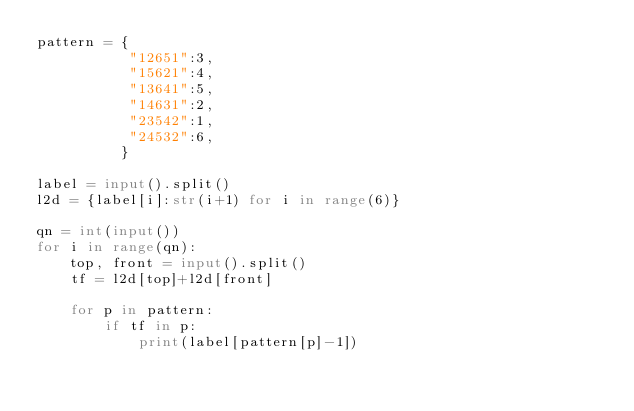Convert code to text. <code><loc_0><loc_0><loc_500><loc_500><_Python_>pattern = {
           "12651":3,
           "15621":4,
           "13641":5,
           "14631":2,
           "23542":1,
           "24532":6,
          }

label = input().split()
l2d = {label[i]:str(i+1) for i in range(6)}

qn = int(input())
for i in range(qn):
    top, front = input().split()
    tf = l2d[top]+l2d[front]

    for p in pattern:
        if tf in p:
            print(label[pattern[p]-1])</code> 